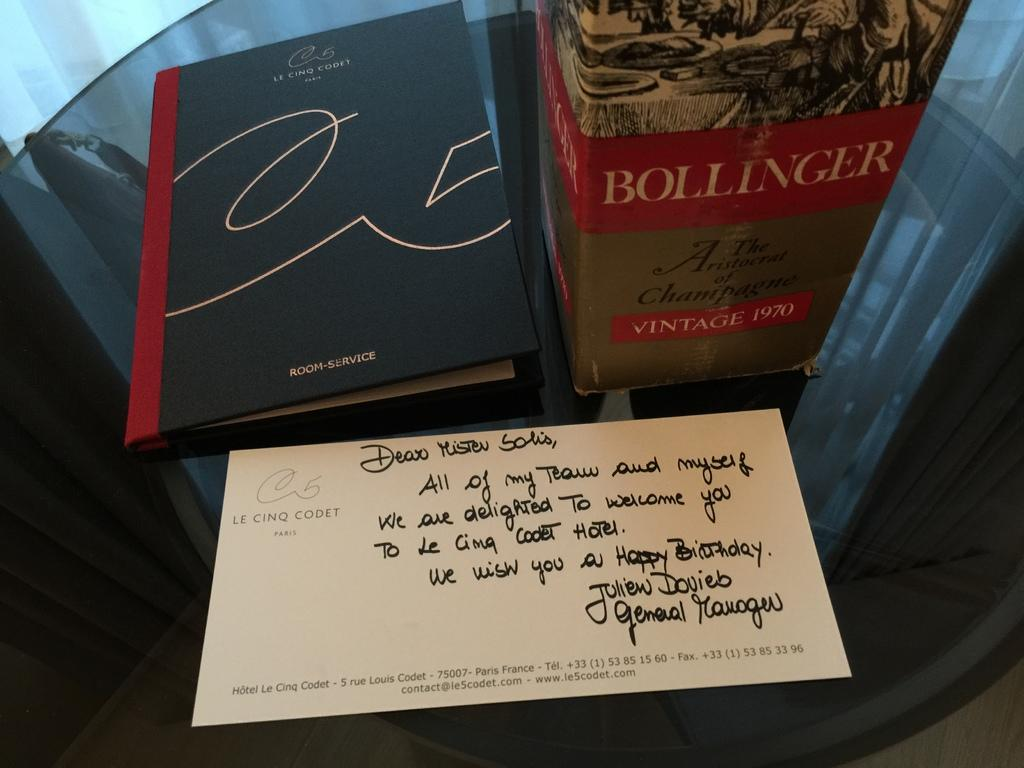<image>
Share a concise interpretation of the image provided. A book is on a table by some vintage champagne from 1970 and a hand written note. 